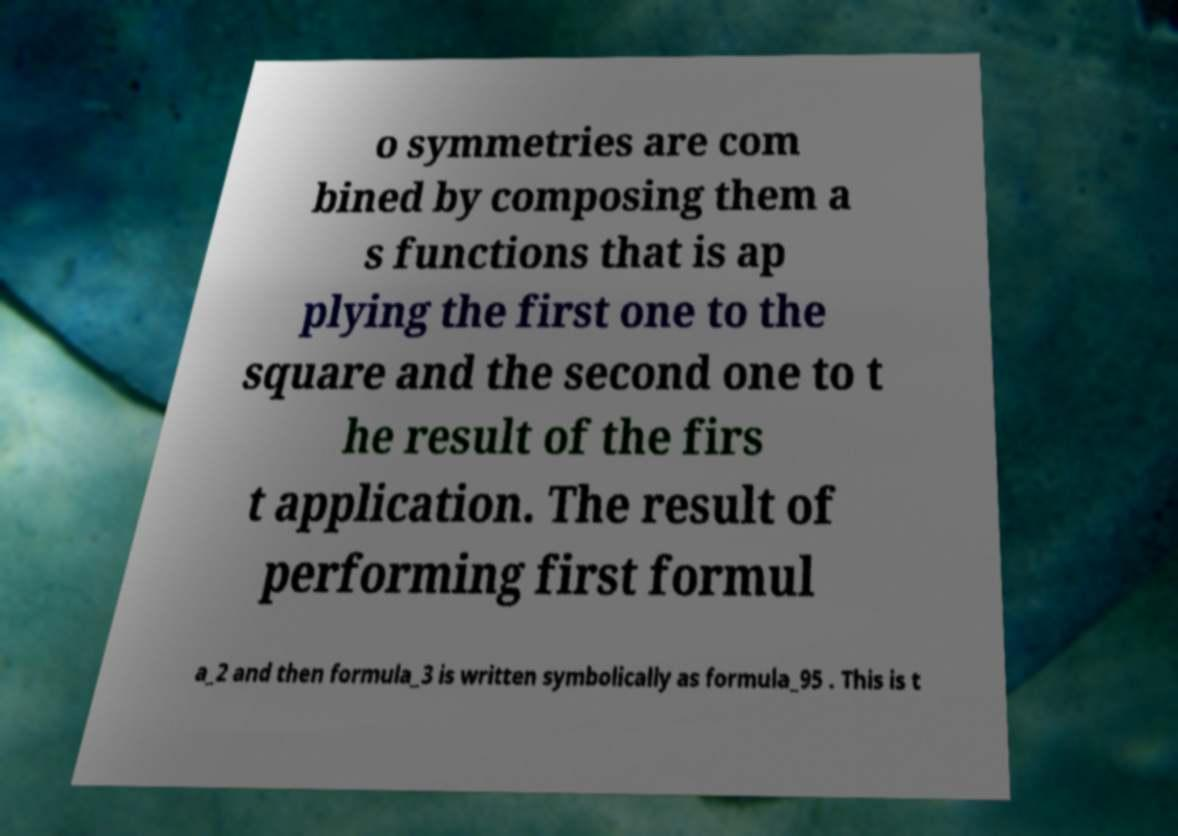Could you assist in decoding the text presented in this image and type it out clearly? o symmetries are com bined by composing them a s functions that is ap plying the first one to the square and the second one to t he result of the firs t application. The result of performing first formul a_2 and then formula_3 is written symbolically as formula_95 . This is t 